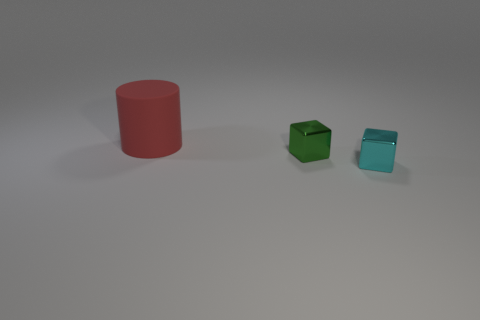Is there any other thing that has the same shape as the big red rubber thing?
Keep it short and to the point. No. There is another object that is the same shape as the cyan shiny object; what is its size?
Offer a terse response. Small. What number of objects are things that are in front of the red matte cylinder or objects in front of the big red rubber cylinder?
Keep it short and to the point. 2. There is a tiny metallic thing that is in front of the tiny shiny cube that is behind the cyan thing; what is its shape?
Make the answer very short. Cube. Are there any other things that are the same color as the cylinder?
Your response must be concise. No. Are there any other things that have the same size as the matte cylinder?
Provide a short and direct response. No. What number of things are either big objects or tiny cubes?
Keep it short and to the point. 3. Is there another metal cube of the same size as the green shiny cube?
Offer a terse response. Yes. The cyan thing is what shape?
Your answer should be very brief. Cube. Is the number of cyan shiny objects that are left of the red rubber object greater than the number of tiny metallic blocks that are behind the green block?
Keep it short and to the point. No. 